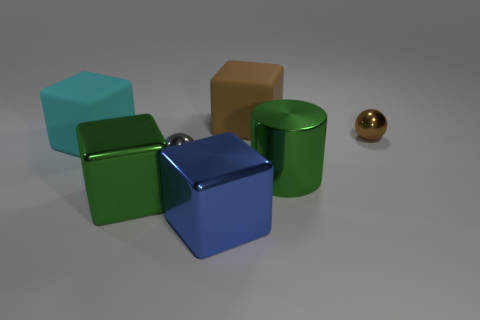Add 1 tiny blue matte spheres. How many objects exist? 8 Subtract all blocks. How many objects are left? 3 Subtract 0 blue balls. How many objects are left? 7 Subtract all big blue cubes. Subtract all large objects. How many objects are left? 1 Add 6 matte blocks. How many matte blocks are left? 8 Add 4 large purple objects. How many large purple objects exist? 4 